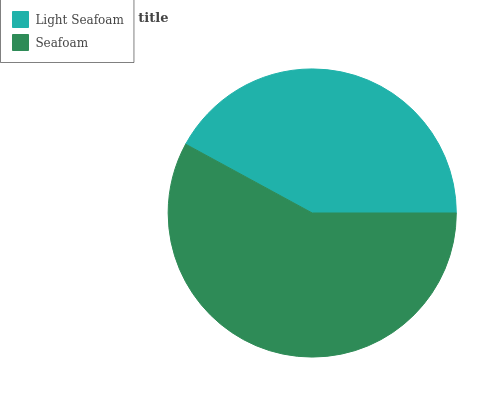Is Light Seafoam the minimum?
Answer yes or no. Yes. Is Seafoam the maximum?
Answer yes or no. Yes. Is Seafoam the minimum?
Answer yes or no. No. Is Seafoam greater than Light Seafoam?
Answer yes or no. Yes. Is Light Seafoam less than Seafoam?
Answer yes or no. Yes. Is Light Seafoam greater than Seafoam?
Answer yes or no. No. Is Seafoam less than Light Seafoam?
Answer yes or no. No. Is Seafoam the high median?
Answer yes or no. Yes. Is Light Seafoam the low median?
Answer yes or no. Yes. Is Light Seafoam the high median?
Answer yes or no. No. Is Seafoam the low median?
Answer yes or no. No. 